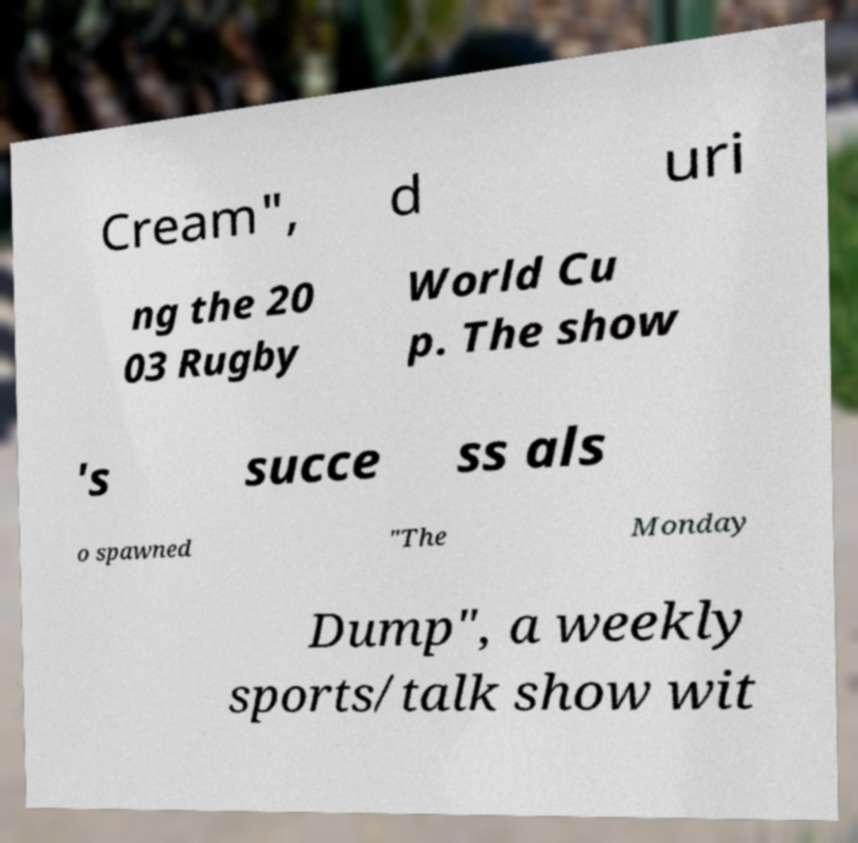What messages or text are displayed in this image? I need them in a readable, typed format. Cream", d uri ng the 20 03 Rugby World Cu p. The show 's succe ss als o spawned "The Monday Dump", a weekly sports/talk show wit 